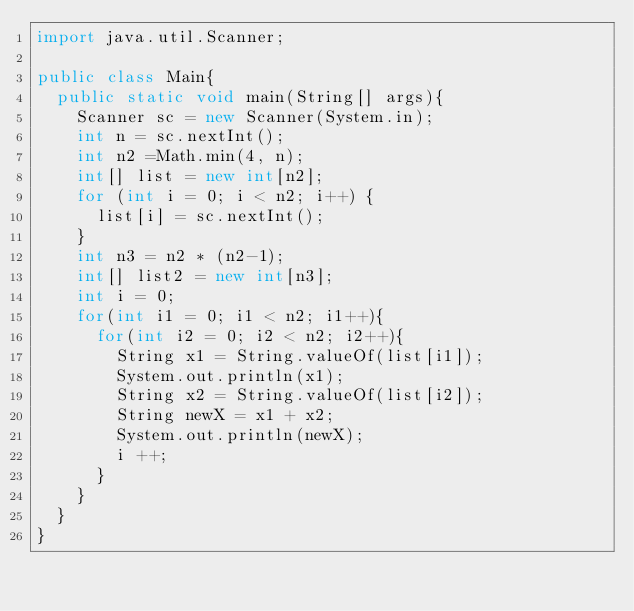Convert code to text. <code><loc_0><loc_0><loc_500><loc_500><_Java_>import java.util.Scanner;

public class Main{
  public static void main(String[] args){
    Scanner sc = new Scanner(System.in);
    int n = sc.nextInt();
    int n2 =Math.min(4, n);
    int[] list = new int[n2];
    for (int i = 0; i < n2; i++) {
      list[i] = sc.nextInt();
    }
    int n3 = n2 * (n2-1);
    int[] list2 = new int[n3];
    int i = 0;
    for(int i1 = 0; i1 < n2; i1++){
      for(int i2 = 0; i2 < n2; i2++){
        String x1 = String.valueOf(list[i1]);
        System.out.println(x1);
        String x2 = String.valueOf(list[i2]);
        String newX = x1 + x2;
        System.out.println(newX);
        i ++;
      }
    }
  }
}
</code> 